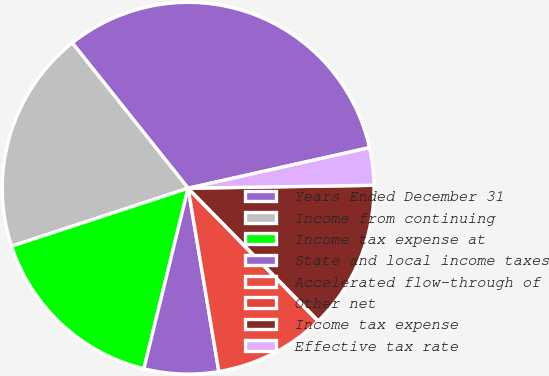Convert chart. <chart><loc_0><loc_0><loc_500><loc_500><pie_chart><fcel>Years Ended December 31<fcel>Income from continuing<fcel>Income tax expense at<fcel>State and local income taxes<fcel>Accelerated flow-through of<fcel>Other net<fcel>Income tax expense<fcel>Effective tax rate<nl><fcel>32.21%<fcel>19.34%<fcel>16.12%<fcel>6.47%<fcel>9.68%<fcel>0.03%<fcel>12.9%<fcel>3.25%<nl></chart> 